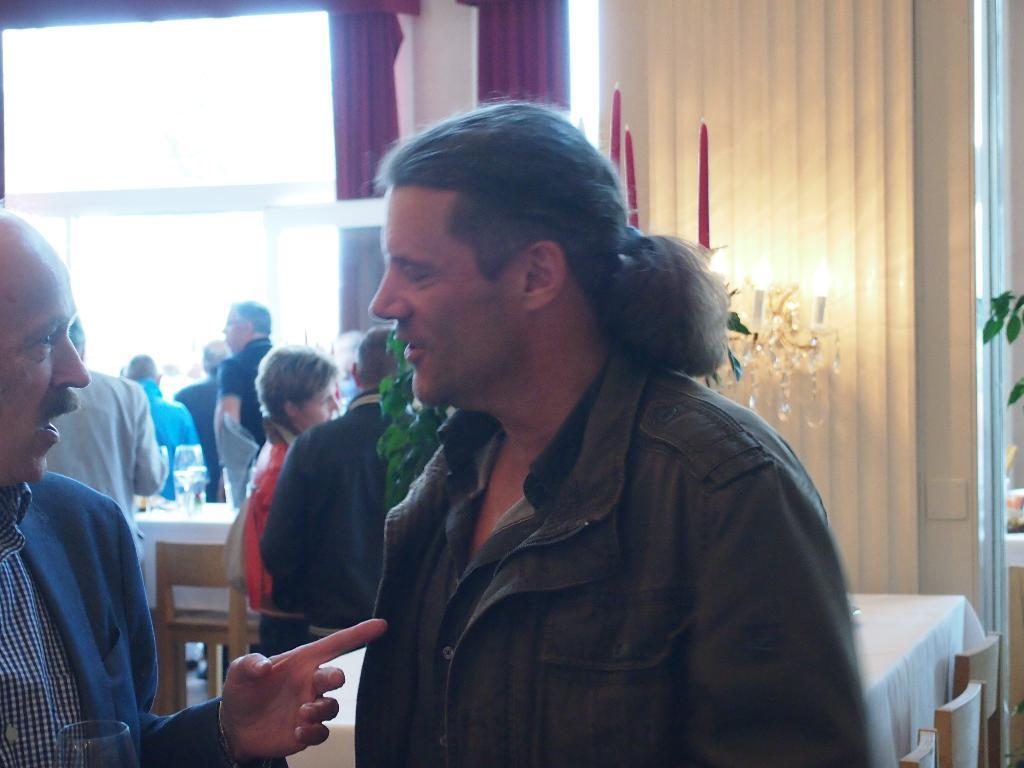What can be seen in the image that allows light to enter a room? There is a window in the image that allows light to enter a room. What is present on the wall in the image? There is a curtain in the image that is hanging on the wall. What is used for illumination in the image? There is a candle and lights in the image that provide illumination. Who is present in the image? There are people standing in the image. What type of furniture is visible in the image? There are tables in the image. What is placed on one of the tables? There is a glass on one of the tables. How many ducks are sitting on the table in the image? There are no ducks present in the image; only a glass is placed on one of the tables. What type of string is used to hold the curtain in the image? There is no mention of string in the image; the curtain is simply hanging on the wall. 